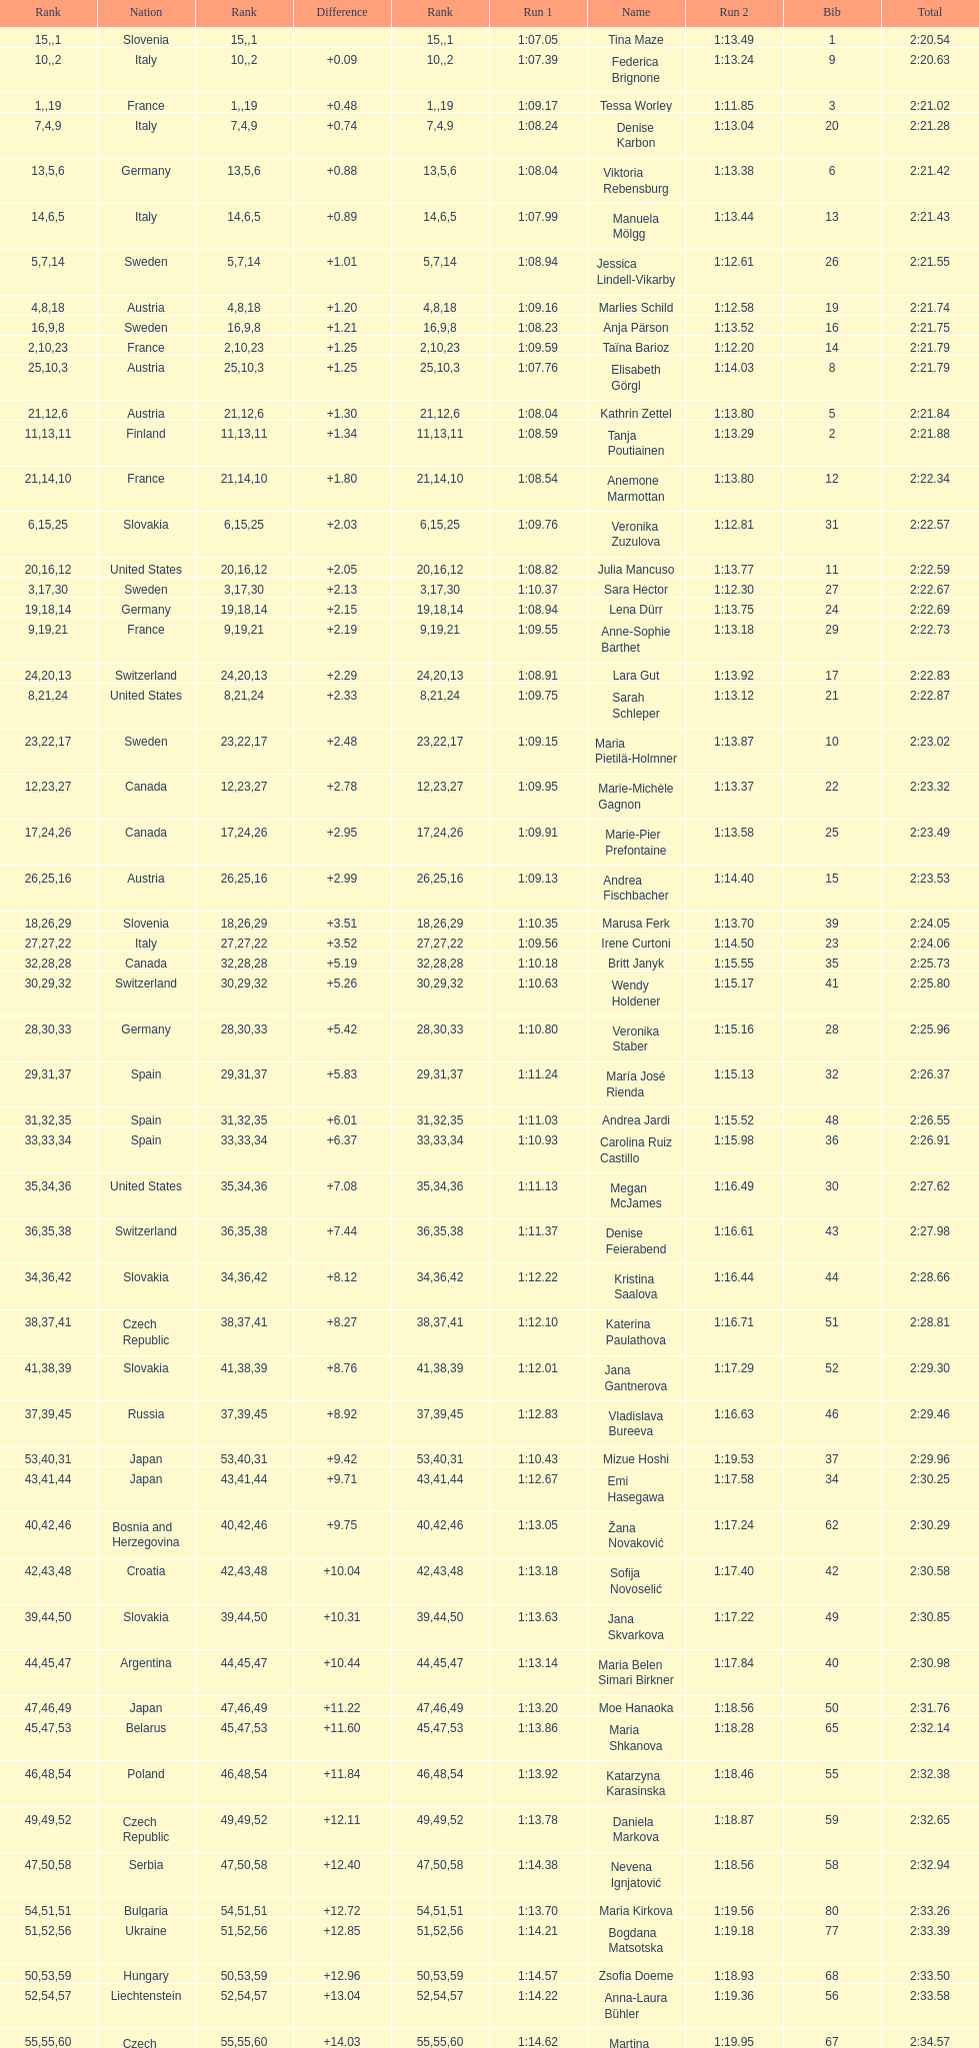Write the full table. {'header': ['Rank', 'Nation', 'Rank', 'Difference', 'Rank', 'Run 1', 'Name', 'Run 2', 'Bib', 'Total'], 'rows': [['15', 'Slovenia', '', '', '1', '1:07.05', 'Tina Maze', '1:13.49', '1', '2:20.54'], ['10', 'Italy', '', '+0.09', '2', '1:07.39', 'Federica Brignone', '1:13.24', '9', '2:20.63'], ['1', 'France', '', '+0.48', '19', '1:09.17', 'Tessa Worley', '1:11.85', '3', '2:21.02'], ['7', 'Italy', '4', '+0.74', '9', '1:08.24', 'Denise Karbon', '1:13.04', '20', '2:21.28'], ['13', 'Germany', '5', '+0.88', '6', '1:08.04', 'Viktoria Rebensburg', '1:13.38', '6', '2:21.42'], ['14', 'Italy', '6', '+0.89', '5', '1:07.99', 'Manuela Mölgg', '1:13.44', '13', '2:21.43'], ['5', 'Sweden', '7', '+1.01', '14', '1:08.94', 'Jessica Lindell-Vikarby', '1:12.61', '26', '2:21.55'], ['4', 'Austria', '8', '+1.20', '18', '1:09.16', 'Marlies Schild', '1:12.58', '19', '2:21.74'], ['16', 'Sweden', '9', '+1.21', '8', '1:08.23', 'Anja Pärson', '1:13.52', '16', '2:21.75'], ['2', 'France', '10', '+1.25', '23', '1:09.59', 'Taïna Barioz', '1:12.20', '14', '2:21.79'], ['25', 'Austria', '10', '+1.25', '3', '1:07.76', 'Elisabeth Görgl', '1:14.03', '8', '2:21.79'], ['21', 'Austria', '12', '+1.30', '6', '1:08.04', 'Kathrin Zettel', '1:13.80', '5', '2:21.84'], ['11', 'Finland', '13', '+1.34', '11', '1:08.59', 'Tanja Poutiainen', '1:13.29', '2', '2:21.88'], ['21', 'France', '14', '+1.80', '10', '1:08.54', 'Anemone Marmottan', '1:13.80', '12', '2:22.34'], ['6', 'Slovakia', '15', '+2.03', '25', '1:09.76', 'Veronika Zuzulova', '1:12.81', '31', '2:22.57'], ['20', 'United States', '16', '+2.05', '12', '1:08.82', 'Julia Mancuso', '1:13.77', '11', '2:22.59'], ['3', 'Sweden', '17', '+2.13', '30', '1:10.37', 'Sara Hector', '1:12.30', '27', '2:22.67'], ['19', 'Germany', '18', '+2.15', '14', '1:08.94', 'Lena Dürr', '1:13.75', '24', '2:22.69'], ['9', 'France', '19', '+2.19', '21', '1:09.55', 'Anne-Sophie Barthet', '1:13.18', '29', '2:22.73'], ['24', 'Switzerland', '20', '+2.29', '13', '1:08.91', 'Lara Gut', '1:13.92', '17', '2:22.83'], ['8', 'United States', '21', '+2.33', '24', '1:09.75', 'Sarah Schleper', '1:13.12', '21', '2:22.87'], ['23', 'Sweden', '22', '+2.48', '17', '1:09.15', 'Maria Pietilä-Holmner', '1:13.87', '10', '2:23.02'], ['12', 'Canada', '23', '+2.78', '27', '1:09.95', 'Marie-Michèle Gagnon', '1:13.37', '22', '2:23.32'], ['17', 'Canada', '24', '+2.95', '26', '1:09.91', 'Marie-Pier Prefontaine', '1:13.58', '25', '2:23.49'], ['26', 'Austria', '25', '+2.99', '16', '1:09.13', 'Andrea Fischbacher', '1:14.40', '15', '2:23.53'], ['18', 'Slovenia', '26', '+3.51', '29', '1:10.35', 'Marusa Ferk', '1:13.70', '39', '2:24.05'], ['27', 'Italy', '27', '+3.52', '22', '1:09.56', 'Irene Curtoni', '1:14.50', '23', '2:24.06'], ['32', 'Canada', '28', '+5.19', '28', '1:10.18', 'Britt Janyk', '1:15.55', '35', '2:25.73'], ['30', 'Switzerland', '29', '+5.26', '32', '1:10.63', 'Wendy Holdener', '1:15.17', '41', '2:25.80'], ['28', 'Germany', '30', '+5.42', '33', '1:10.80', 'Veronika Staber', '1:15.16', '28', '2:25.96'], ['29', 'Spain', '31', '+5.83', '37', '1:11.24', 'María José Rienda', '1:15.13', '32', '2:26.37'], ['31', 'Spain', '32', '+6.01', '35', '1:11.03', 'Andrea Jardi', '1:15.52', '48', '2:26.55'], ['33', 'Spain', '33', '+6.37', '34', '1:10.93', 'Carolina Ruiz Castillo', '1:15.98', '36', '2:26.91'], ['35', 'United States', '34', '+7.08', '36', '1:11.13', 'Megan McJames', '1:16.49', '30', '2:27.62'], ['36', 'Switzerland', '35', '+7.44', '38', '1:11.37', 'Denise Feierabend', '1:16.61', '43', '2:27.98'], ['34', 'Slovakia', '36', '+8.12', '42', '1:12.22', 'Kristina Saalova', '1:16.44', '44', '2:28.66'], ['38', 'Czech Republic', '37', '+8.27', '41', '1:12.10', 'Katerina Paulathova', '1:16.71', '51', '2:28.81'], ['41', 'Slovakia', '38', '+8.76', '39', '1:12.01', 'Jana Gantnerova', '1:17.29', '52', '2:29.30'], ['37', 'Russia', '39', '+8.92', '45', '1:12.83', 'Vladislava Bureeva', '1:16.63', '46', '2:29.46'], ['53', 'Japan', '40', '+9.42', '31', '1:10.43', 'Mizue Hoshi', '1:19.53', '37', '2:29.96'], ['43', 'Japan', '41', '+9.71', '44', '1:12.67', 'Emi Hasegawa', '1:17.58', '34', '2:30.25'], ['40', 'Bosnia and Herzegovina', '42', '+9.75', '46', '1:13.05', 'Žana Novaković', '1:17.24', '62', '2:30.29'], ['42', 'Croatia', '43', '+10.04', '48', '1:13.18', 'Sofija Novoselić', '1:17.40', '42', '2:30.58'], ['39', 'Slovakia', '44', '+10.31', '50', '1:13.63', 'Jana Skvarkova', '1:17.22', '49', '2:30.85'], ['44', 'Argentina', '45', '+10.44', '47', '1:13.14', 'Maria Belen Simari Birkner', '1:17.84', '40', '2:30.98'], ['47', 'Japan', '46', '+11.22', '49', '1:13.20', 'Moe Hanaoka', '1:18.56', '50', '2:31.76'], ['45', 'Belarus', '47', '+11.60', '53', '1:13.86', 'Maria Shkanova', '1:18.28', '65', '2:32.14'], ['46', 'Poland', '48', '+11.84', '54', '1:13.92', 'Katarzyna Karasinska', '1:18.46', '55', '2:32.38'], ['49', 'Czech Republic', '49', '+12.11', '52', '1:13.78', 'Daniela Markova', '1:18.87', '59', '2:32.65'], ['47', 'Serbia', '50', '+12.40', '58', '1:14.38', 'Nevena Ignjatović', '1:18.56', '58', '2:32.94'], ['54', 'Bulgaria', '51', '+12.72', '51', '1:13.70', 'Maria Kirkova', '1:19.56', '80', '2:33.26'], ['51', 'Ukraine', '52', '+12.85', '56', '1:14.21', 'Bogdana Matsotska', '1:19.18', '77', '2:33.39'], ['50', 'Hungary', '53', '+12.96', '59', '1:14.57', 'Zsofia Doeme', '1:18.93', '68', '2:33.50'], ['52', 'Liechtenstein', '54', '+13.04', '57', '1:14.22', 'Anna-Laura Bühler', '1:19.36', '56', '2:33.58'], ['55', 'Czech Republic', '55', '+14.03', '60', '1:14.62', 'Martina Dubovska', '1:19.95', '67', '2:34.57'], ['', 'Germany', '', '', '20', '1:09.41', 'Kathrin Hölzl', 'DNS', '7', ''], ['', 'Germany', '', '', '4', '1:07.86', 'Maria Riesch', 'DNF', '4', ''], ['', 'Liechtenstein', '', '', '40', '1:12.03', 'Rebecca Bühler', 'DNF', '38', ''], ['', 'Liechtenstein', '', '', '43', '1:12.47', 'Vanessa Schädler', 'DNF', '47', ''], ['', 'Iceland', '', '', '55', '1:13.93', 'Iris Gudmundsdottir', 'DNF', '69', ''], ['', 'Croatia', '', '', '61', '1:14.73', 'Tea Palić', 'DNQ', '45', ''], ['', 'Argentina', '', '', '62', '1:15.18', 'Macarena Simari Birkner', 'DNQ', '74', ''], ['', 'Australia', '', '', '63', '1:15.35', 'Lavinia Chrystal', 'DNQ', '72', ''], ['', 'Latvia', '', '', '64', '1:15.37', 'Lelde Gasuna', 'DNQ', '81', ''], ['', 'Poland', '', '', '65', '1:15.41', 'Aleksandra Klus', 'DNQ', '64', ''], ['', 'Georgia', '', '', '66', '1:15.54', 'Nino Tsiklauri', 'DNQ', '78', ''], ['', 'New Zealand', '', '', '67', '1:15.94', 'Sarah Jarvis', 'DNQ', '66', ''], ['', 'Hungary', '', '', '68', '1:15.95', 'Anna Berecz', 'DNQ', '61', ''], ['', 'Romania', '', '', '69', '1:16.67', 'Sandra-Elena Narea', 'DNQ', '83', ''], ['', 'Romania', '', '', '70', '1:16.80', 'Iulia Petruta Craciun', 'DNQ', '85', ''], ['', 'Belgium', '', '', '71', '1:17.06', 'Isabel van Buynder', 'DNQ', '82', ''], ['', 'Latvia', '', '', '72', '1:17.83', 'Liene Fimbauere', 'DNQ', '97', ''], ['', 'Puerto Rico', '', '', '73', '1:17.93', 'Kristina Krone', 'DNQ', '86', ''], ['', 'Greece', '', '', '74', '1:18.19', 'Nicole Valcareggi', 'DNQ', '88', ''], ['', 'Denmark', '', '', '75', '1:18.37', 'Sophie Fjellvang-Sølling', 'DNQ', '100', ''], ['', 'Peru', '', '', '76', '1:18.61', 'Ornella Oettl Reyes', 'DNQ', '95', ''], ['', 'China', '', '', '77', '1:19.12', 'Xia Lina', 'DNQ', '73', ''], ['', 'Uzbekistan', '', '', '78', '1:19.16', 'Kseniya Grigoreva', 'DNQ', '94', ''], ['', 'Turkey', '', '', '79', '1:21.50', 'Tugba Dasdemir', 'DNQ', '87', ''], ['', 'Denmark', '', '', '80', '1:22.25', 'Malene Madsen', 'DNQ', '92', ''], ['', 'China', '', '', '81', '1:22.80', 'Liu Yang', 'DNQ', '84', ''], ['', 'Israel', '', '', '82', '1:22.87', 'Yom Hirshfeld', 'DNQ', '91', ''], ['', 'Argentina', '', '', '83', '1:23.08', 'Salome Bancora', 'DNQ', '75', ''], ['', 'Israel', '', '', '84', '1:23.38', 'Ronnie Kiek-Gedalyahu', 'DNQ', '93', ''], ['', 'Brazil', '', '', '85', '1:24.16', 'Chiara Marano', 'DNQ', '96', ''], ['', 'Denmark', '', '', '86', '1:25.08', 'Anne Libak Nielsen', 'DNQ', '113', ''], ['', 'Hungary', '', '', '87', '1:26.97', 'Donata Hellner', 'DNQ', '105', ''], ['', 'China', '', '', '88', '1:27.03', 'Liu Yu', 'DNQ', '102', ''], ['', 'Kyrgyzstan', '', '', '89', '1:27.17', 'Lida Zvoznikova', 'DNQ', '109', ''], ['', 'Hungary', '', '', '90', '1:27.27', 'Szelina Hellner', 'DNQ', '103', ''], ['', 'Kyrgyzstan', '', '', '91', '1:29.73', 'Irina Volkova', 'DNQ', '114', ''], ['', 'Uzbekistan', '', '', '92', '1:30.62', 'Svetlana Baranova', 'DNQ', '106', ''], ['', 'Uzbekistan', '', '', '93', '1:31.81', 'Tatjana Baranova', 'DNQ', '108', ''], ['', 'Iran', '', '', '94', '1:32.16', 'Fatemeh Kiadarbandsari', 'DNQ', '110', ''], ['', 'Iran', '', '', '95', '1:32.64', 'Ziba Kalhor', 'DNQ', '107', ''], ['', 'Greece', '', '', '96', '1:32.83', 'Paraskevi Mavridou', 'DNQ', '104', ''], ['', 'Iran', '', '', '97', '1:34.94', 'Marjan Kalhor', 'DNQ', '99', ''], ['', 'Iran', '', '', '98', '1:37.93', 'Mitra Kalhor', 'DNQ', '112', ''], ['', 'South Africa', '', '', '99', '1:42.19', 'Laura Bauer', 'DNQ', '115', ''], ['', 'Lebanon', '', '', '100', '1:42.22', 'Sarah Ekmekejian', 'DNQ', '111', ''], ['', 'Switzerland', '', '', '', 'DNS', 'Fabienne Suter', '', '18', ''], ['', 'Bosnia and Herzegovina', '', '', '', 'DNS', 'Maja Klepić', '', '98', ''], ['', 'Poland', '', '', '', 'DNF', 'Agniezska Gasienica Daniel', '', '33', ''], ['', 'Poland', '', '', '', 'DNF', 'Karolina Chrapek', '', '53', ''], ['', 'Andorra', '', '', '', 'DNF', 'Mireia Gutierrez', '', '54', ''], ['', 'Canada', '', '', '', 'DNF', 'Brittany Phelan', '', '57', ''], ['', 'Czech Republic', '', '', '', 'DNF', 'Tereza Kmochova', '', '60', ''], ['', 'Netherlands', '', '', '', 'DNF', 'Michelle van Herwerden', '', '63', ''], ['', 'Brazil', '', '', '', 'DNF', 'Maya Harrisson', '', '70', ''], ['', 'Australia', '', '', '', 'DNF', 'Elizabeth Pilat', '', '71', ''], ['', 'Iceland', '', '', '', 'DNF', 'Katrin Kristjansdottir', '', '76', ''], ['', 'Argentina', '', '', '', 'DNF', 'Julietta Quiroga', '', '79', ''], ['', 'Latvia', '', '', '', 'DNF', 'Evija Benhena', '', '89', ''], ['', 'China', '', '', '', 'DNF', 'Qin Xiyue', '', '90', ''], ['', 'Greece', '', '', '', 'DNF', 'Sophia Ralli', '', '101', ''], ['', 'Armenia', '', '', '', 'DNF', 'Siranush Maghakyan', '', '116', '']]} Who ranked next after federica brignone? Tessa Worley. 